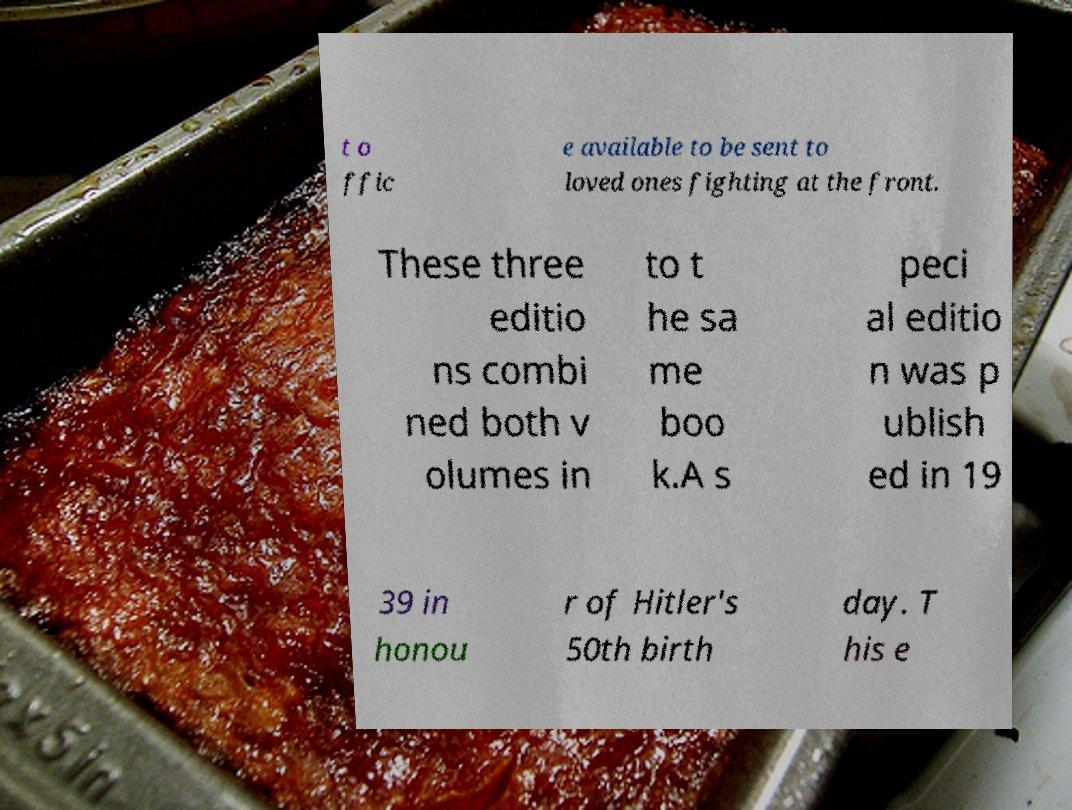There's text embedded in this image that I need extracted. Can you transcribe it verbatim? t o ffic e available to be sent to loved ones fighting at the front. These three editio ns combi ned both v olumes in to t he sa me boo k.A s peci al editio n was p ublish ed in 19 39 in honou r of Hitler's 50th birth day. T his e 